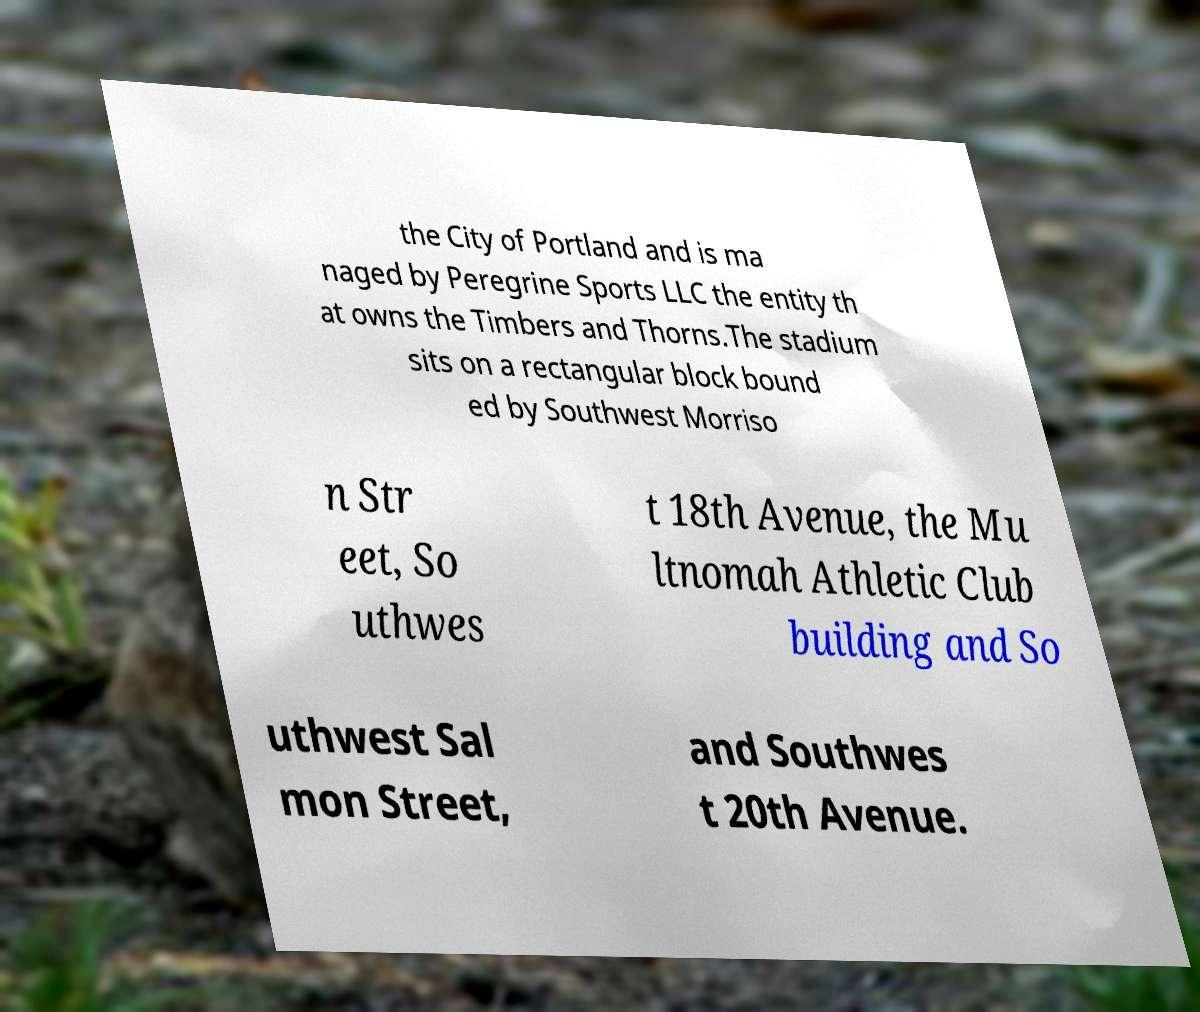Can you accurately transcribe the text from the provided image for me? the City of Portland and is ma naged by Peregrine Sports LLC the entity th at owns the Timbers and Thorns.The stadium sits on a rectangular block bound ed by Southwest Morriso n Str eet, So uthwes t 18th Avenue, the Mu ltnomah Athletic Club building and So uthwest Sal mon Street, and Southwes t 20th Avenue. 